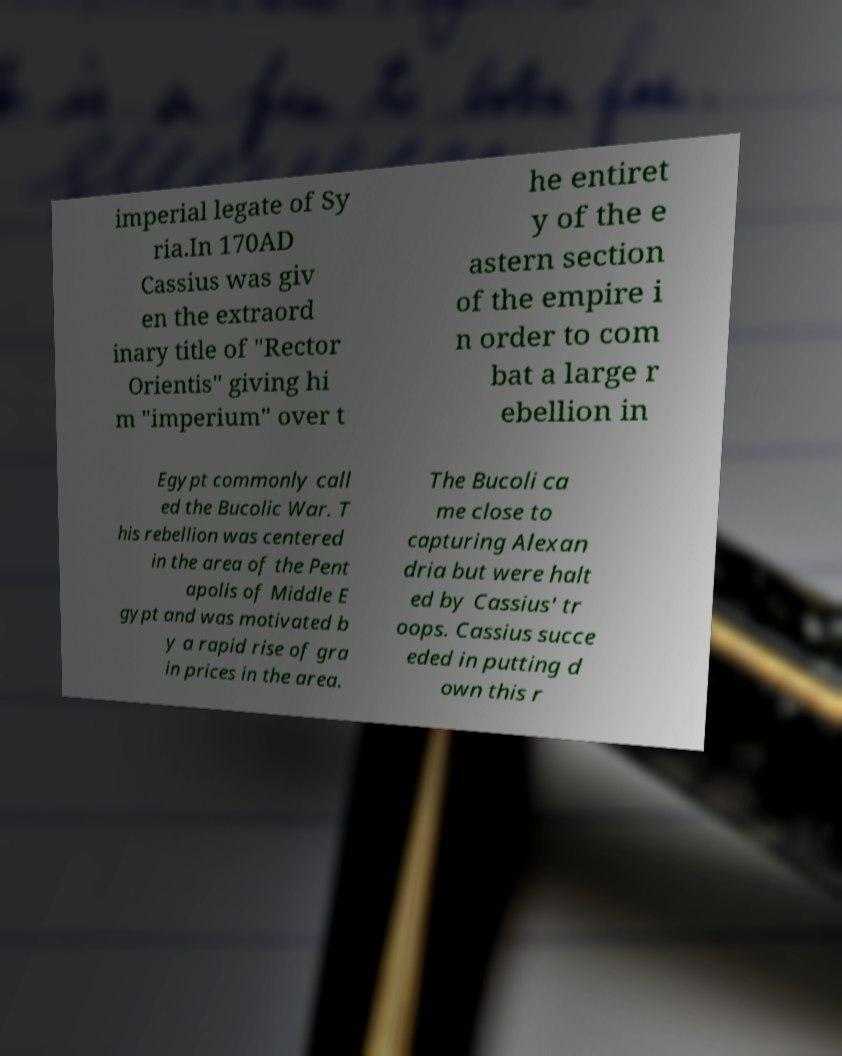Could you assist in decoding the text presented in this image and type it out clearly? imperial legate of Sy ria.In 170AD Cassius was giv en the extraord inary title of "Rector Orientis" giving hi m "imperium" over t he entiret y of the e astern section of the empire i n order to com bat a large r ebellion in Egypt commonly call ed the Bucolic War. T his rebellion was centered in the area of the Pent apolis of Middle E gypt and was motivated b y a rapid rise of gra in prices in the area. The Bucoli ca me close to capturing Alexan dria but were halt ed by Cassius' tr oops. Cassius succe eded in putting d own this r 